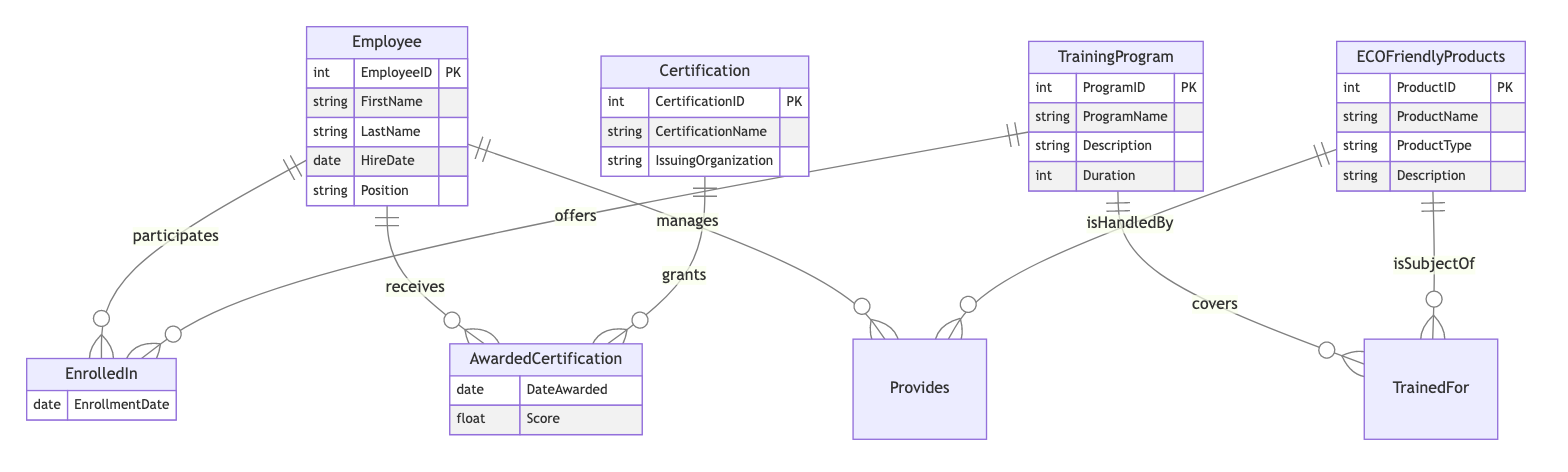what is the primary key of the Employee entity? The primary key for the Employee entity is EmployeeID, which uniquely identifies each employee in the database.
Answer: EmployeeID how many attributes does the Certification entity possess? The Certification entity has three attributes: CertificationID, CertificationName, and IssuingOrganization.
Answer: 3 what relationship connects Employee and TrainingProgram? The relationship that connects Employee and TrainingProgram is called EnrolledIn, indicating that employees can enroll in various training programs.
Answer: EnrolledIn who grants the AwardedCertification? The Certification entity grants the AwardedCertification, meaning that a specific certification is provided upon an employee's successful achievement.
Answer: Certification how many entities are present in the diagram? The diagram contains four entities: Employee, TrainingProgram, Certification, and ECOFriendlyProducts, which represent different aspects of the training and certification paths.
Answer: 4 which entity is managed by Employee? ECOFriendlyProducts is managed by Employee, as reflected in the Provides relationship that indicates employees handle various eco-friendly products.
Answer: ECOFriendlyProducts when was the EnrollmentDate recorded? The EnrollmentDate is recorded in the relationship named EnrolledIn, which tracks when an employee started a specific training program.
Answer: EnrolledIn which attribute specifies the duration of a TrainingProgram? The attribute that specifies the duration of a TrainingProgram is Duration, detailing how long the training program lasts.
Answer: Duration what is the purpose of the TrainedFor relationship? The TrainedFor relationship indicates which training programs are designed to prepare employees for specific ECOFriendlyProducts, showcasing the focus of each program.
Answer: describes training relevance 